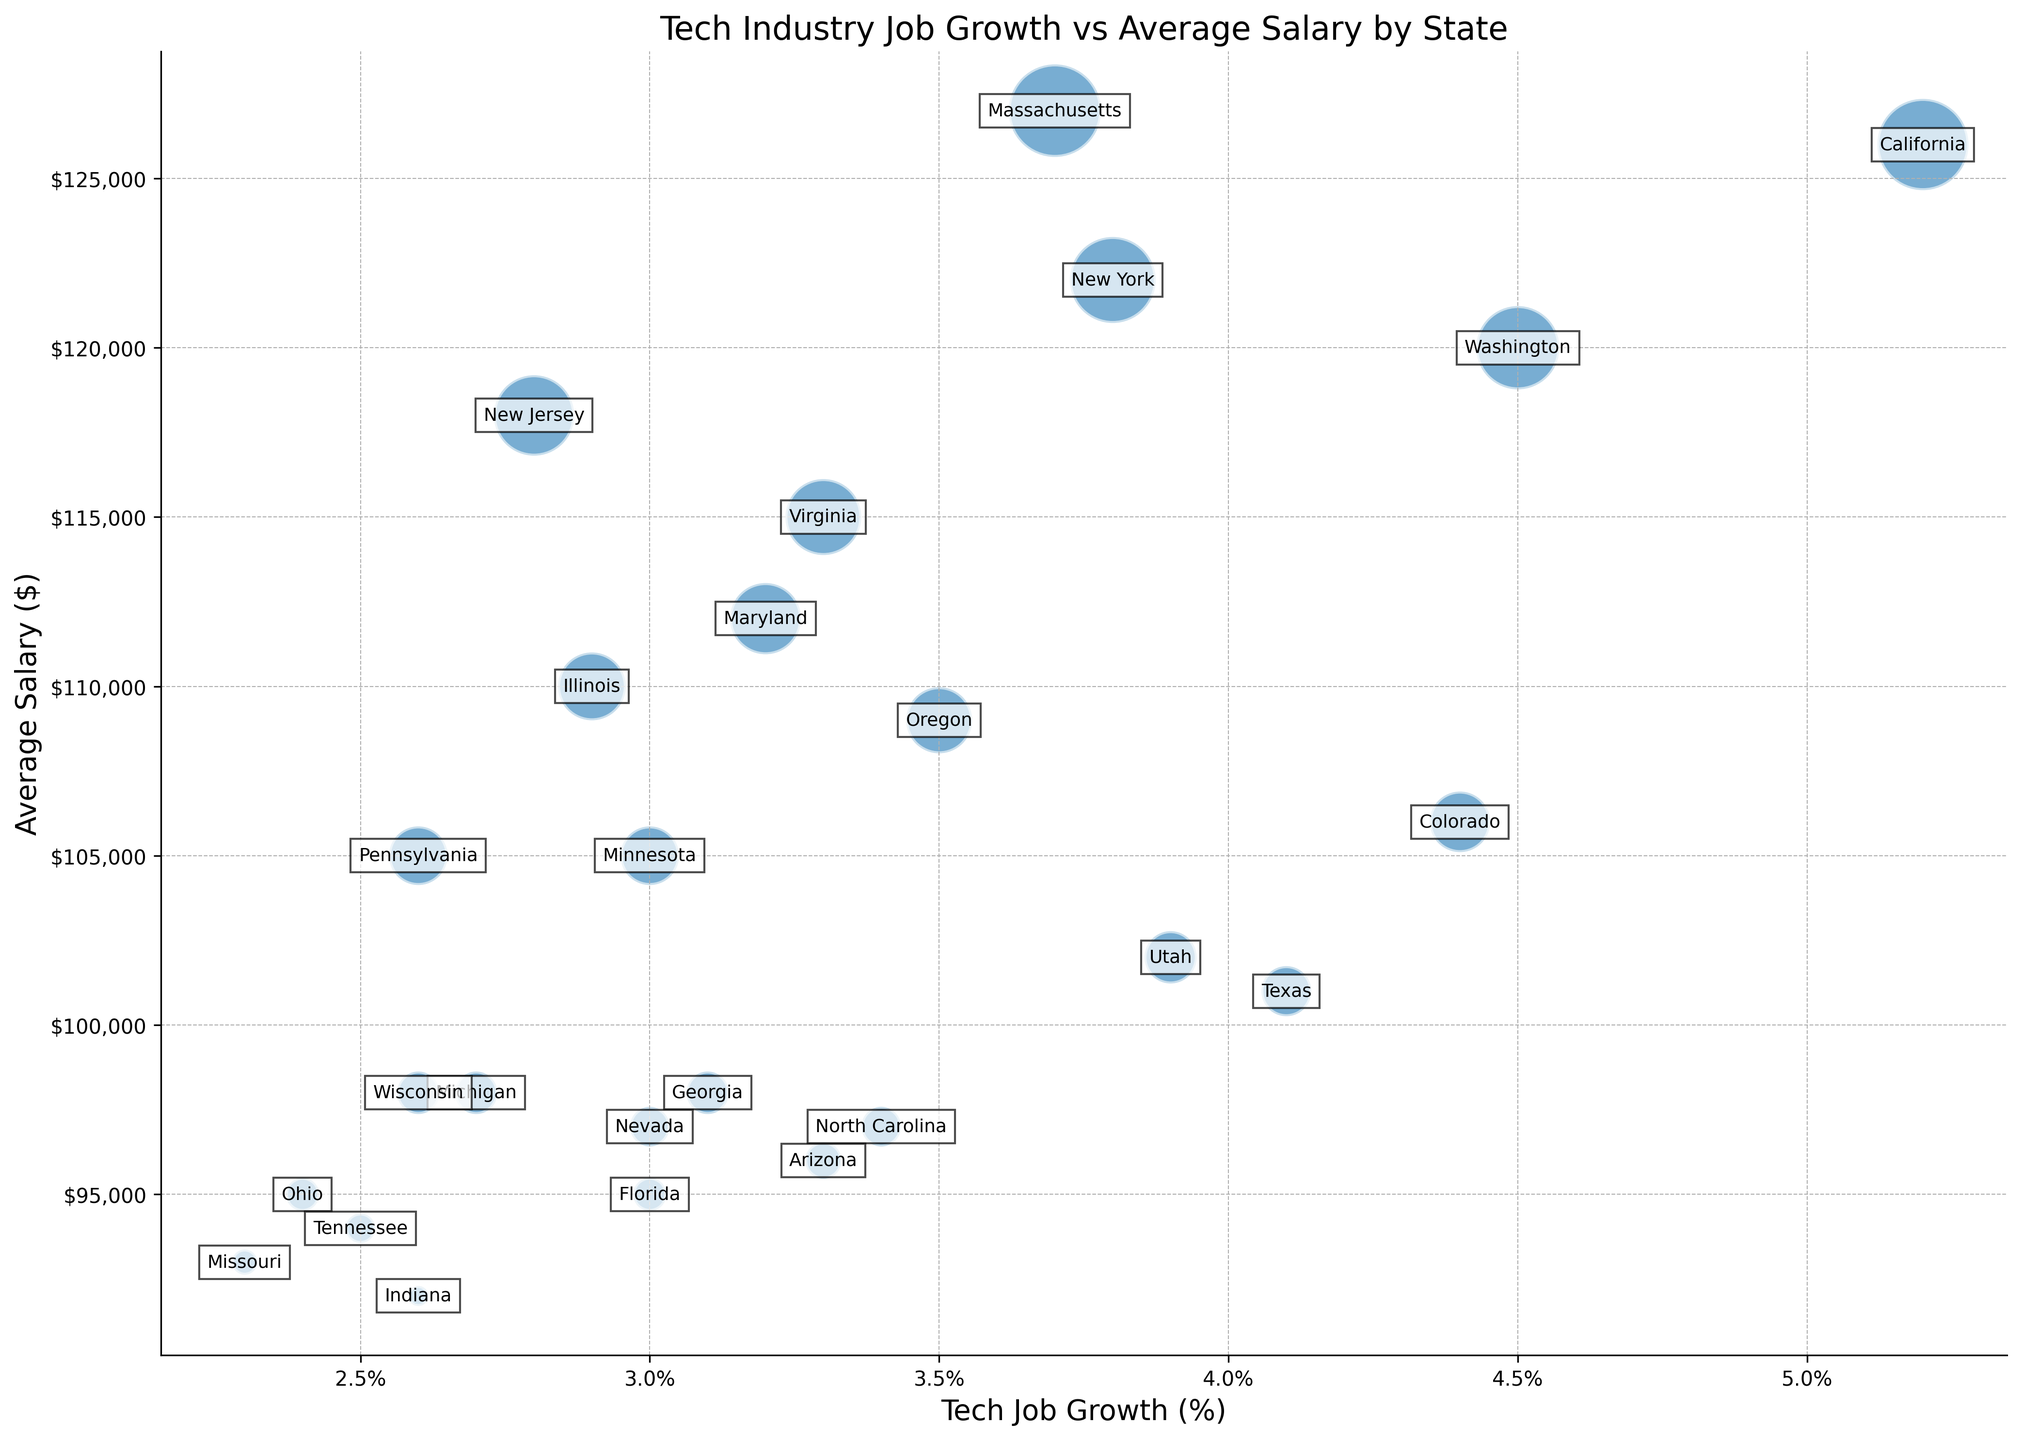What state has the highest average salary in the tech industry? By examining the y-axis, the state with the bubble positioned highest vertically represents the highest average salary.
Answer: Massachusetts Which state shows the lowest tech job growth percentage? The state with the bubble positioned furthest to the left on the x-axis has the lowest tech job growth percentage.
Answer: Missouri Compare the average salaries of California and Texas. Which state has a higher salary, and by how much? California's bubble is positioned higher on the y-axis compared to Texas's bubble, indicating a higher average salary. California's salary is $126,000, and Texas's salary is $101,000. The difference is $126,000 - $101,000.
Answer: California, $25,000 Find the states with tech job growth percentages above 4%. How many states meet this criterion? Bubbles positioned to the right of the 4% mark on the x-axis represent states with more than 4% tech job growth. Those states are California, Washington, and Colorado.
Answer: 3 states Which state has both a lower-than-average salary and tech job growth? To identify this, we need to find bubbles that are positioned left of the average job growth (around 3.5%) and below the average salary (approximately $107,000). Missouri meets both criteria.
Answer: Missouri Does New Jersey have a higher average salary than Illinois? New Jersey's bubble is positioned higher on the y-axis compared to Illinois's bubble. Hence, New Jersey has a higher average salary.
Answer: Yes Compare the average salaries of New York and Washington. What is the percentage difference between them? New York's average salary is $122,000, while Washington's average salary is $120,000. The percentage difference is calculated as ((122,000 - 120,000) / 120,000) * 100.
Answer: About 1.67% Which state with tech job growth below 3% has the highest average salary? For states left of the 3% mark on the x-axis, find the bubble highest on the y-axis. New Jersey, with an average salary of $118,000, meets this condition.
Answer: New Jersey Identify the state with the smallest bubble size. What does this imply about the average salary in that state? The smallest bubble represents the lowest average salary. Indiana has the smallest bubble, implying its average salary is $92,000, the lowest among the states listed.
Answer: Indiana Is there a state with an average salary of $100,000 or more but a tech job growth rate below 3%? If so, name it. Examining states with bubbles positioned to the left of 3% on the x-axis, Illinois has an average salary of $110,000, which meets the criteria.
Answer: Illinois 